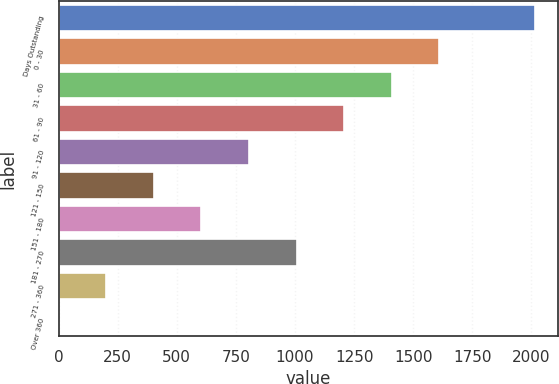Convert chart to OTSL. <chart><loc_0><loc_0><loc_500><loc_500><bar_chart><fcel>Days Outstanding<fcel>0 - 30<fcel>31 - 60<fcel>61 - 90<fcel>91 - 120<fcel>121 - 150<fcel>151 - 180<fcel>181 - 270<fcel>271 - 360<fcel>Over 360<nl><fcel>2013<fcel>1610.46<fcel>1409.19<fcel>1207.92<fcel>805.38<fcel>402.84<fcel>604.11<fcel>1006.65<fcel>201.57<fcel>0.3<nl></chart> 